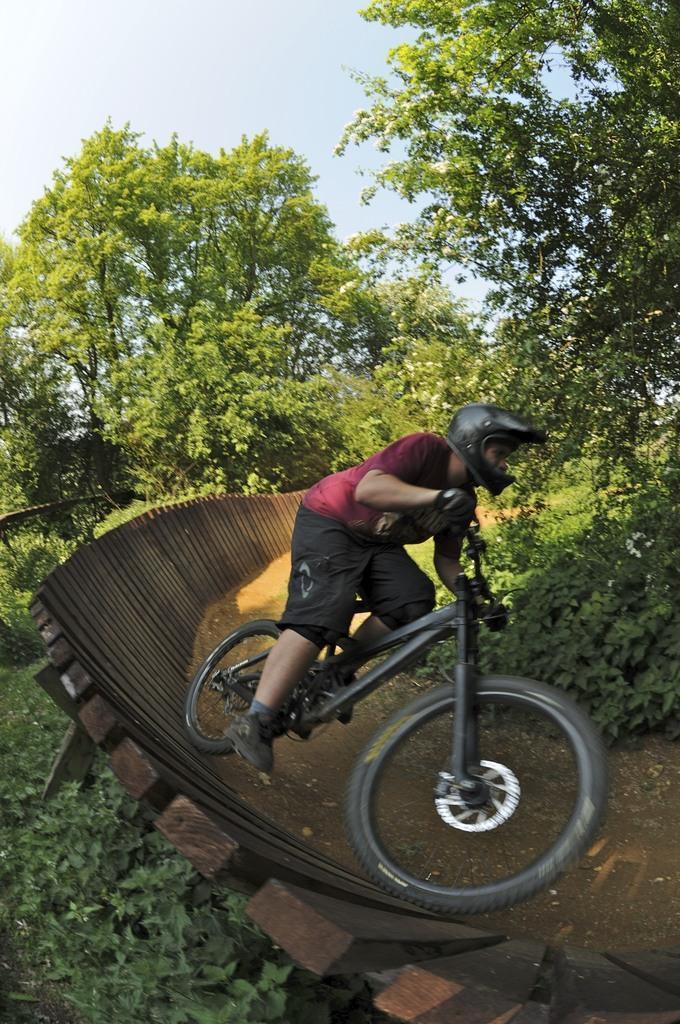Describe this image in one or two sentences. Here we can see one person is riding a cycle he is wearing helmet. And coming to the back ground we can see some trees and sky with clouds. 